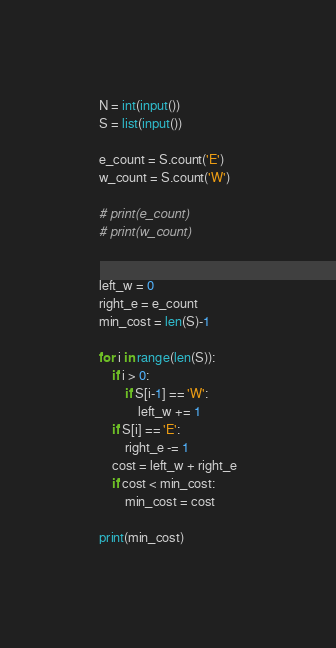Convert code to text. <code><loc_0><loc_0><loc_500><loc_500><_Python_>N = int(input())
S = list(input())

e_count = S.count('E')
w_count = S.count('W')

# print(e_count)
# print(w_count)


left_w = 0
right_e = e_count
min_cost = len(S)-1

for i in range(len(S)):
    if i > 0:
        if S[i-1] == 'W':
            left_w += 1
    if S[i] == 'E':
        right_e -= 1
    cost = left_w + right_e
    if cost < min_cost:
        min_cost = cost

print(min_cost)
</code> 